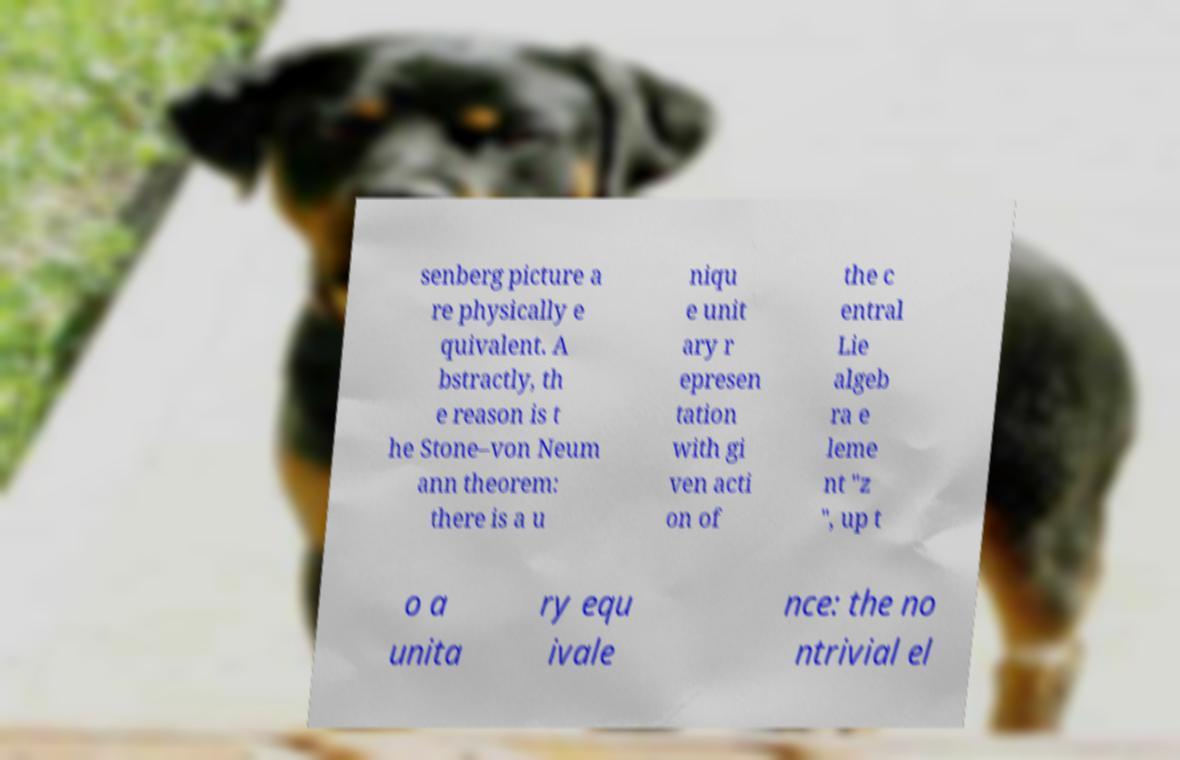Can you accurately transcribe the text from the provided image for me? senberg picture a re physically e quivalent. A bstractly, th e reason is t he Stone–von Neum ann theorem: there is a u niqu e unit ary r epresen tation with gi ven acti on of the c entral Lie algeb ra e leme nt "z ", up t o a unita ry equ ivale nce: the no ntrivial el 